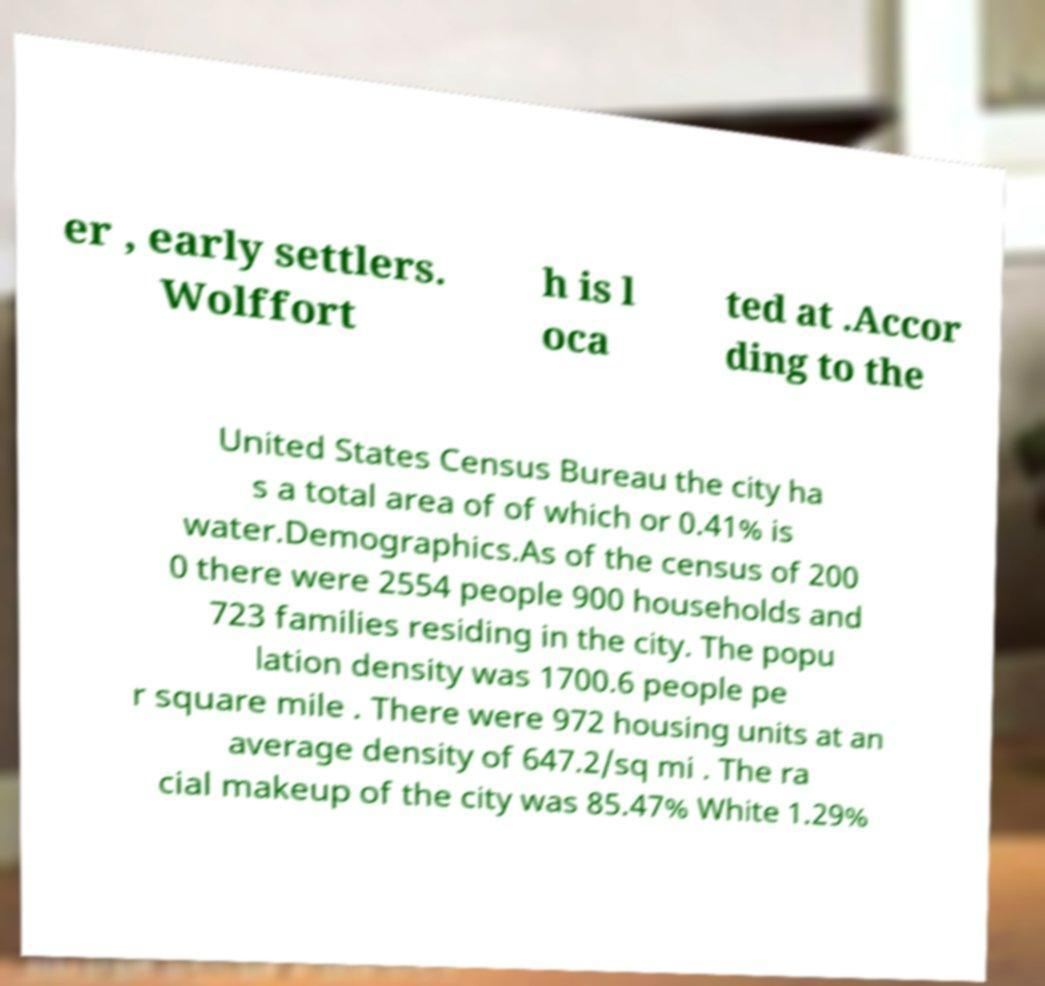Please identify and transcribe the text found in this image. er , early settlers. Wolffort h is l oca ted at .Accor ding to the United States Census Bureau the city ha s a total area of of which or 0.41% is water.Demographics.As of the census of 200 0 there were 2554 people 900 households and 723 families residing in the city. The popu lation density was 1700.6 people pe r square mile . There were 972 housing units at an average density of 647.2/sq mi . The ra cial makeup of the city was 85.47% White 1.29% 